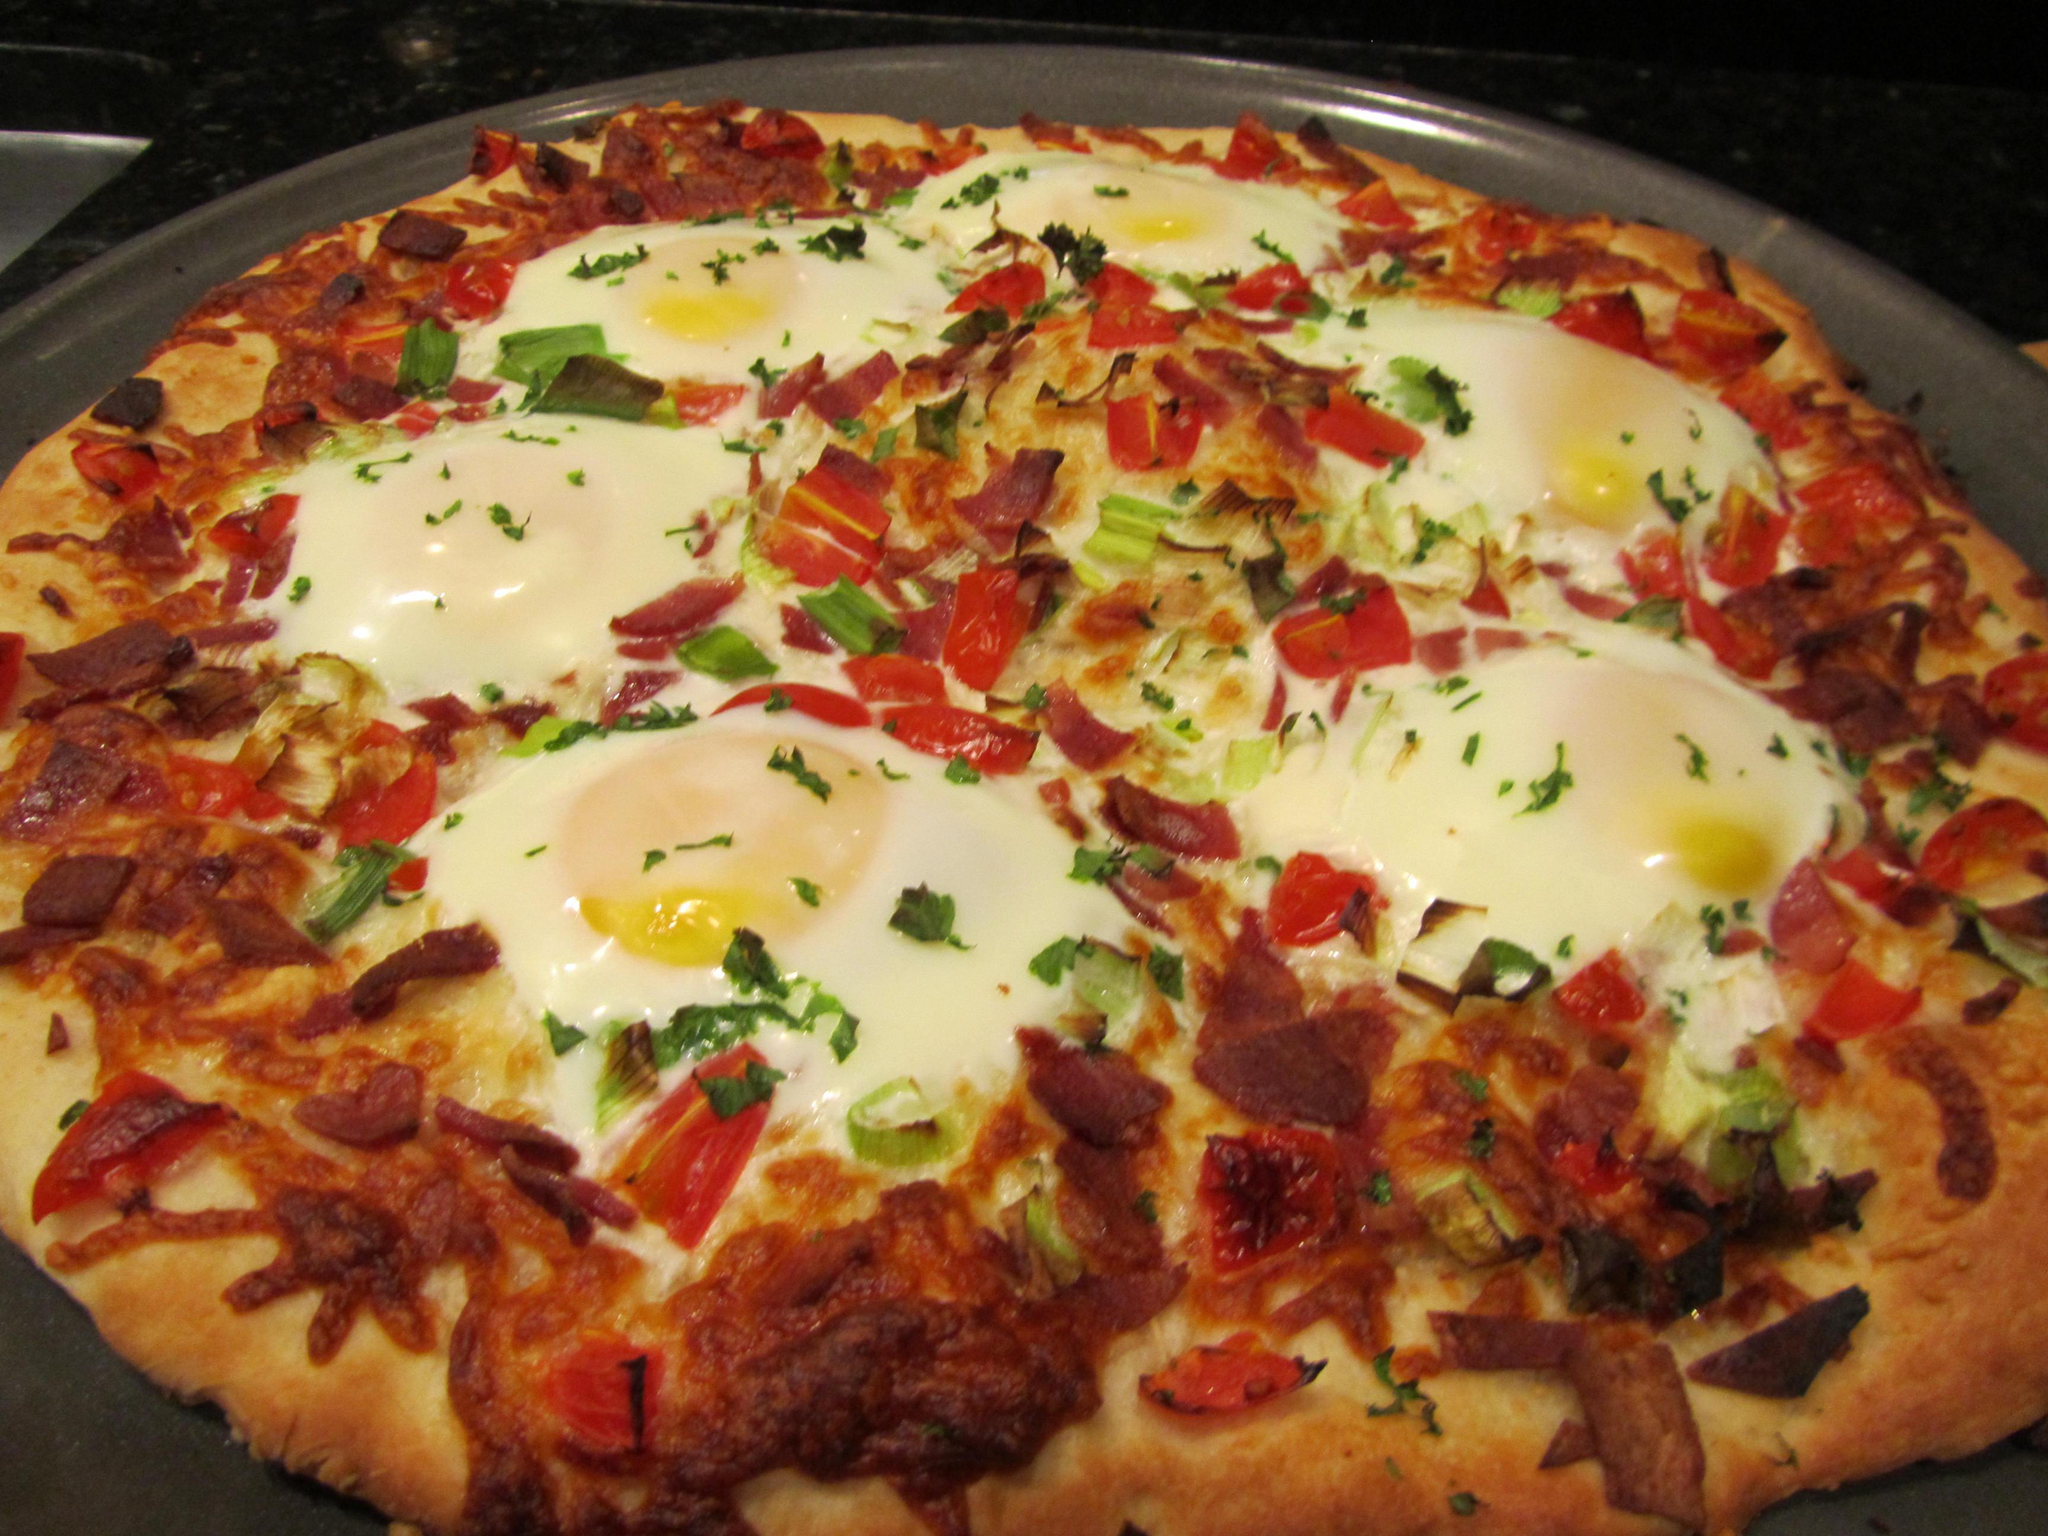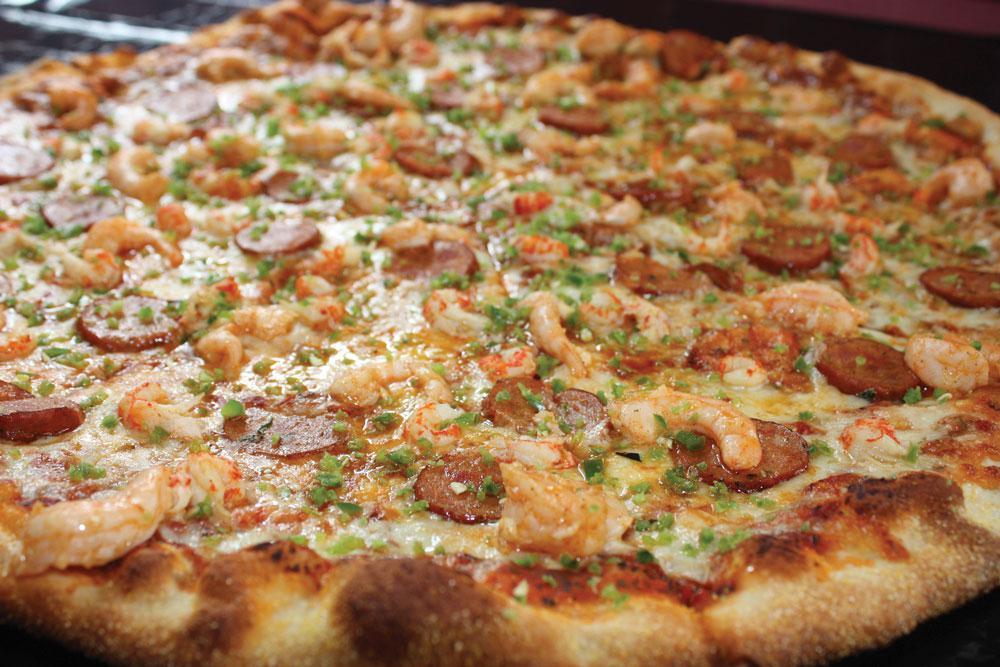The first image is the image on the left, the second image is the image on the right. Examine the images to the left and right. Is the description "One image shows an unsliced pizza, and the other image features less than an entire pizza but at least one slice." accurate? Answer yes or no. No. The first image is the image on the left, the second image is the image on the right. Examine the images to the left and right. Is the description "The left and right image contains the same number of full pizzas." accurate? Answer yes or no. Yes. 